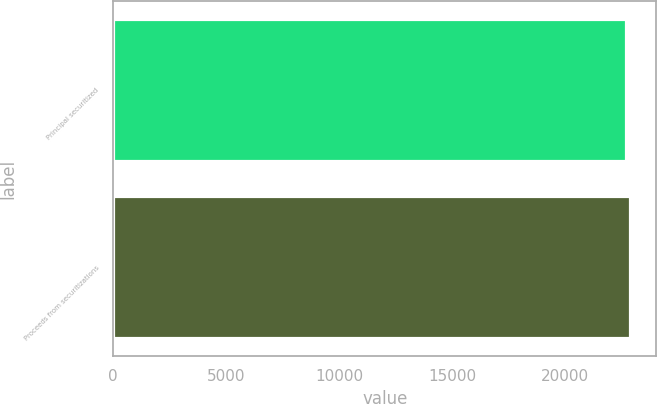Convert chart. <chart><loc_0><loc_0><loc_500><loc_500><bar_chart><fcel>Principal securitized<fcel>Proceeds from securitizations<nl><fcel>22691<fcel>22892<nl></chart> 